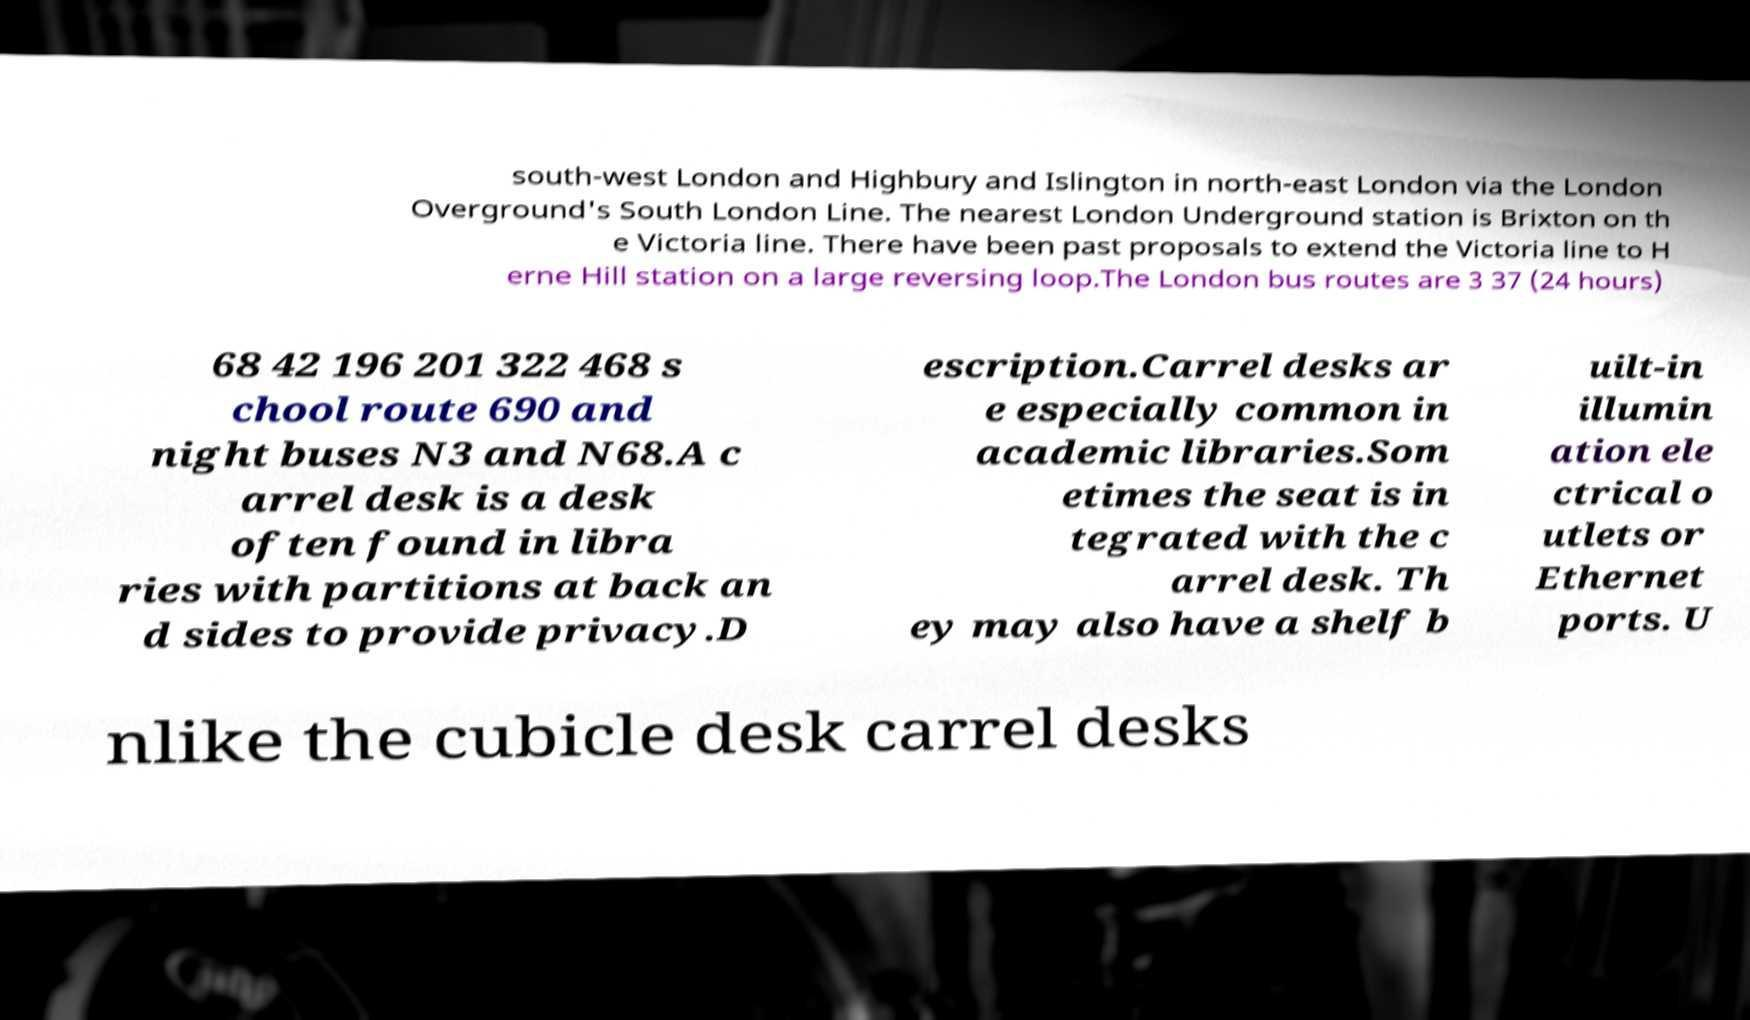Could you assist in decoding the text presented in this image and type it out clearly? south-west London and Highbury and Islington in north-east London via the London Overground's South London Line. The nearest London Underground station is Brixton on th e Victoria line. There have been past proposals to extend the Victoria line to H erne Hill station on a large reversing loop.The London bus routes are 3 37 (24 hours) 68 42 196 201 322 468 s chool route 690 and night buses N3 and N68.A c arrel desk is a desk often found in libra ries with partitions at back an d sides to provide privacy.D escription.Carrel desks ar e especially common in academic libraries.Som etimes the seat is in tegrated with the c arrel desk. Th ey may also have a shelf b uilt-in illumin ation ele ctrical o utlets or Ethernet ports. U nlike the cubicle desk carrel desks 